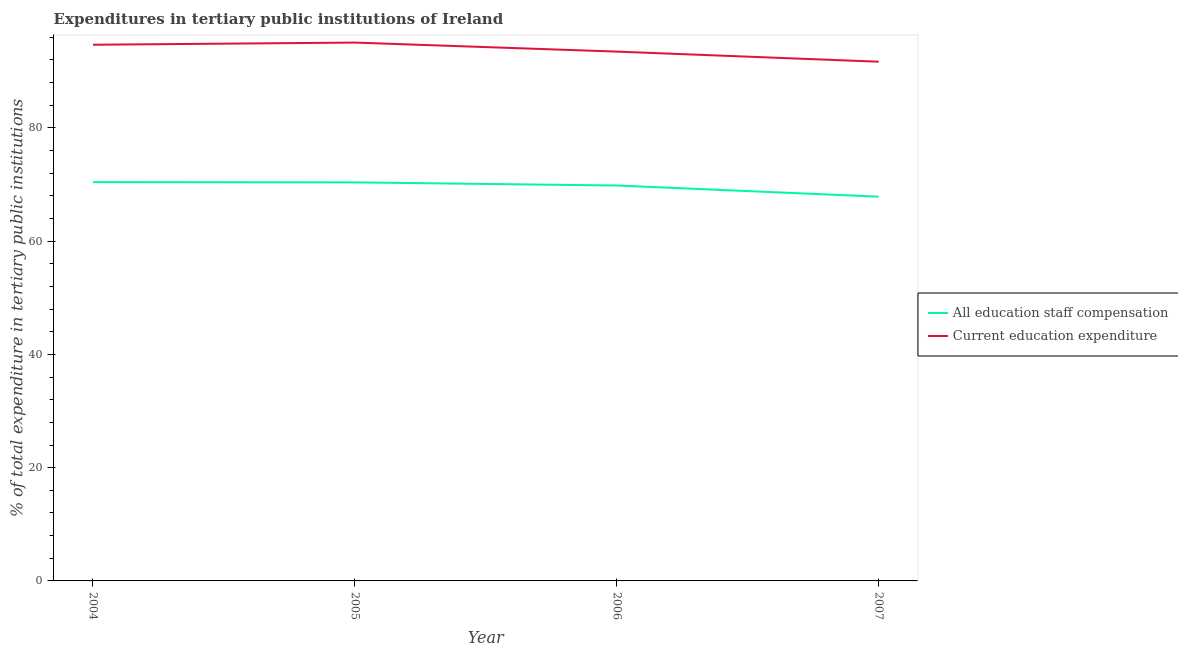How many different coloured lines are there?
Your answer should be very brief. 2. What is the expenditure in staff compensation in 2004?
Offer a very short reply. 70.42. Across all years, what is the maximum expenditure in staff compensation?
Keep it short and to the point. 70.42. Across all years, what is the minimum expenditure in education?
Provide a succinct answer. 91.68. In which year was the expenditure in staff compensation maximum?
Offer a very short reply. 2004. What is the total expenditure in education in the graph?
Provide a succinct answer. 374.89. What is the difference between the expenditure in staff compensation in 2006 and that in 2007?
Offer a terse response. 1.97. What is the difference between the expenditure in education in 2004 and the expenditure in staff compensation in 2006?
Ensure brevity in your answer.  24.86. What is the average expenditure in education per year?
Your answer should be compact. 93.72. In the year 2004, what is the difference between the expenditure in staff compensation and expenditure in education?
Provide a short and direct response. -24.26. What is the ratio of the expenditure in education in 2005 to that in 2006?
Give a very brief answer. 1.02. Is the expenditure in staff compensation in 2005 less than that in 2007?
Your response must be concise. No. Is the difference between the expenditure in education in 2005 and 2006 greater than the difference between the expenditure in staff compensation in 2005 and 2006?
Provide a short and direct response. Yes. What is the difference between the highest and the second highest expenditure in education?
Keep it short and to the point. 0.38. What is the difference between the highest and the lowest expenditure in education?
Offer a terse response. 3.38. In how many years, is the expenditure in staff compensation greater than the average expenditure in staff compensation taken over all years?
Your answer should be very brief. 3. Does the expenditure in staff compensation monotonically increase over the years?
Your answer should be compact. No. Is the expenditure in staff compensation strictly greater than the expenditure in education over the years?
Your response must be concise. No. What is the difference between two consecutive major ticks on the Y-axis?
Ensure brevity in your answer.  20. Does the graph contain any zero values?
Offer a very short reply. No. Does the graph contain grids?
Provide a succinct answer. No. What is the title of the graph?
Your answer should be very brief. Expenditures in tertiary public institutions of Ireland. What is the label or title of the X-axis?
Provide a short and direct response. Year. What is the label or title of the Y-axis?
Provide a short and direct response. % of total expenditure in tertiary public institutions. What is the % of total expenditure in tertiary public institutions of All education staff compensation in 2004?
Your answer should be compact. 70.42. What is the % of total expenditure in tertiary public institutions of Current education expenditure in 2004?
Make the answer very short. 94.68. What is the % of total expenditure in tertiary public institutions of All education staff compensation in 2005?
Your answer should be very brief. 70.38. What is the % of total expenditure in tertiary public institutions of Current education expenditure in 2005?
Offer a very short reply. 95.06. What is the % of total expenditure in tertiary public institutions in All education staff compensation in 2006?
Provide a succinct answer. 69.82. What is the % of total expenditure in tertiary public institutions of Current education expenditure in 2006?
Offer a very short reply. 93.47. What is the % of total expenditure in tertiary public institutions of All education staff compensation in 2007?
Give a very brief answer. 67.85. What is the % of total expenditure in tertiary public institutions of Current education expenditure in 2007?
Your answer should be compact. 91.68. Across all years, what is the maximum % of total expenditure in tertiary public institutions in All education staff compensation?
Provide a short and direct response. 70.42. Across all years, what is the maximum % of total expenditure in tertiary public institutions of Current education expenditure?
Offer a terse response. 95.06. Across all years, what is the minimum % of total expenditure in tertiary public institutions in All education staff compensation?
Provide a succinct answer. 67.85. Across all years, what is the minimum % of total expenditure in tertiary public institutions of Current education expenditure?
Offer a terse response. 91.68. What is the total % of total expenditure in tertiary public institutions of All education staff compensation in the graph?
Keep it short and to the point. 278.47. What is the total % of total expenditure in tertiary public institutions in Current education expenditure in the graph?
Offer a terse response. 374.89. What is the difference between the % of total expenditure in tertiary public institutions in All education staff compensation in 2004 and that in 2005?
Your response must be concise. 0.05. What is the difference between the % of total expenditure in tertiary public institutions of Current education expenditure in 2004 and that in 2005?
Offer a terse response. -0.38. What is the difference between the % of total expenditure in tertiary public institutions in All education staff compensation in 2004 and that in 2006?
Offer a very short reply. 0.6. What is the difference between the % of total expenditure in tertiary public institutions of Current education expenditure in 2004 and that in 2006?
Your answer should be very brief. 1.21. What is the difference between the % of total expenditure in tertiary public institutions in All education staff compensation in 2004 and that in 2007?
Your answer should be very brief. 2.57. What is the difference between the % of total expenditure in tertiary public institutions of Current education expenditure in 2004 and that in 2007?
Your answer should be very brief. 3. What is the difference between the % of total expenditure in tertiary public institutions of All education staff compensation in 2005 and that in 2006?
Ensure brevity in your answer.  0.55. What is the difference between the % of total expenditure in tertiary public institutions of Current education expenditure in 2005 and that in 2006?
Give a very brief answer. 1.59. What is the difference between the % of total expenditure in tertiary public institutions of All education staff compensation in 2005 and that in 2007?
Ensure brevity in your answer.  2.53. What is the difference between the % of total expenditure in tertiary public institutions of Current education expenditure in 2005 and that in 2007?
Make the answer very short. 3.38. What is the difference between the % of total expenditure in tertiary public institutions of All education staff compensation in 2006 and that in 2007?
Provide a short and direct response. 1.97. What is the difference between the % of total expenditure in tertiary public institutions in Current education expenditure in 2006 and that in 2007?
Offer a very short reply. 1.78. What is the difference between the % of total expenditure in tertiary public institutions in All education staff compensation in 2004 and the % of total expenditure in tertiary public institutions in Current education expenditure in 2005?
Your answer should be very brief. -24.64. What is the difference between the % of total expenditure in tertiary public institutions of All education staff compensation in 2004 and the % of total expenditure in tertiary public institutions of Current education expenditure in 2006?
Provide a short and direct response. -23.04. What is the difference between the % of total expenditure in tertiary public institutions of All education staff compensation in 2004 and the % of total expenditure in tertiary public institutions of Current education expenditure in 2007?
Your answer should be very brief. -21.26. What is the difference between the % of total expenditure in tertiary public institutions of All education staff compensation in 2005 and the % of total expenditure in tertiary public institutions of Current education expenditure in 2006?
Provide a succinct answer. -23.09. What is the difference between the % of total expenditure in tertiary public institutions in All education staff compensation in 2005 and the % of total expenditure in tertiary public institutions in Current education expenditure in 2007?
Your answer should be compact. -21.31. What is the difference between the % of total expenditure in tertiary public institutions of All education staff compensation in 2006 and the % of total expenditure in tertiary public institutions of Current education expenditure in 2007?
Provide a succinct answer. -21.86. What is the average % of total expenditure in tertiary public institutions in All education staff compensation per year?
Your response must be concise. 69.62. What is the average % of total expenditure in tertiary public institutions in Current education expenditure per year?
Your answer should be very brief. 93.72. In the year 2004, what is the difference between the % of total expenditure in tertiary public institutions in All education staff compensation and % of total expenditure in tertiary public institutions in Current education expenditure?
Offer a very short reply. -24.26. In the year 2005, what is the difference between the % of total expenditure in tertiary public institutions in All education staff compensation and % of total expenditure in tertiary public institutions in Current education expenditure?
Your answer should be very brief. -24.68. In the year 2006, what is the difference between the % of total expenditure in tertiary public institutions of All education staff compensation and % of total expenditure in tertiary public institutions of Current education expenditure?
Provide a short and direct response. -23.64. In the year 2007, what is the difference between the % of total expenditure in tertiary public institutions in All education staff compensation and % of total expenditure in tertiary public institutions in Current education expenditure?
Give a very brief answer. -23.84. What is the ratio of the % of total expenditure in tertiary public institutions in All education staff compensation in 2004 to that in 2005?
Keep it short and to the point. 1. What is the ratio of the % of total expenditure in tertiary public institutions in Current education expenditure in 2004 to that in 2005?
Offer a terse response. 1. What is the ratio of the % of total expenditure in tertiary public institutions of All education staff compensation in 2004 to that in 2006?
Ensure brevity in your answer.  1.01. What is the ratio of the % of total expenditure in tertiary public institutions in All education staff compensation in 2004 to that in 2007?
Your response must be concise. 1.04. What is the ratio of the % of total expenditure in tertiary public institutions of Current education expenditure in 2004 to that in 2007?
Keep it short and to the point. 1.03. What is the ratio of the % of total expenditure in tertiary public institutions of All education staff compensation in 2005 to that in 2006?
Offer a terse response. 1.01. What is the ratio of the % of total expenditure in tertiary public institutions in Current education expenditure in 2005 to that in 2006?
Make the answer very short. 1.02. What is the ratio of the % of total expenditure in tertiary public institutions in All education staff compensation in 2005 to that in 2007?
Offer a terse response. 1.04. What is the ratio of the % of total expenditure in tertiary public institutions in Current education expenditure in 2005 to that in 2007?
Give a very brief answer. 1.04. What is the ratio of the % of total expenditure in tertiary public institutions of All education staff compensation in 2006 to that in 2007?
Make the answer very short. 1.03. What is the ratio of the % of total expenditure in tertiary public institutions in Current education expenditure in 2006 to that in 2007?
Your answer should be very brief. 1.02. What is the difference between the highest and the second highest % of total expenditure in tertiary public institutions of All education staff compensation?
Keep it short and to the point. 0.05. What is the difference between the highest and the second highest % of total expenditure in tertiary public institutions of Current education expenditure?
Provide a succinct answer. 0.38. What is the difference between the highest and the lowest % of total expenditure in tertiary public institutions of All education staff compensation?
Provide a succinct answer. 2.57. What is the difference between the highest and the lowest % of total expenditure in tertiary public institutions of Current education expenditure?
Keep it short and to the point. 3.38. 